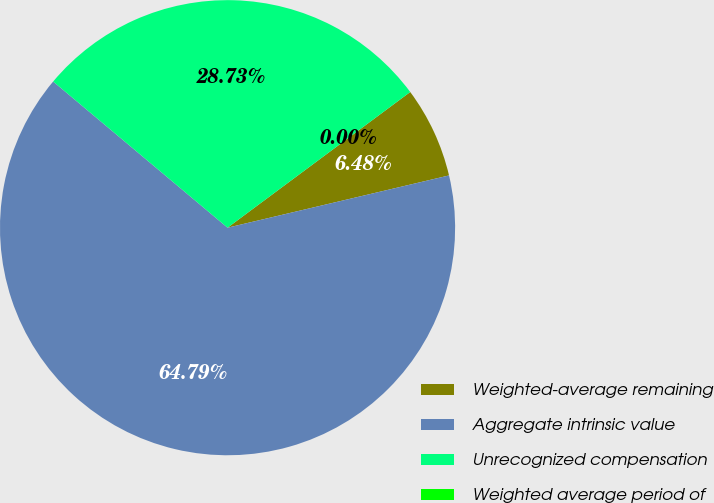Convert chart to OTSL. <chart><loc_0><loc_0><loc_500><loc_500><pie_chart><fcel>Weighted-average remaining<fcel>Aggregate intrinsic value<fcel>Unrecognized compensation<fcel>Weighted average period of<nl><fcel>6.48%<fcel>64.79%<fcel>28.73%<fcel>0.0%<nl></chart> 